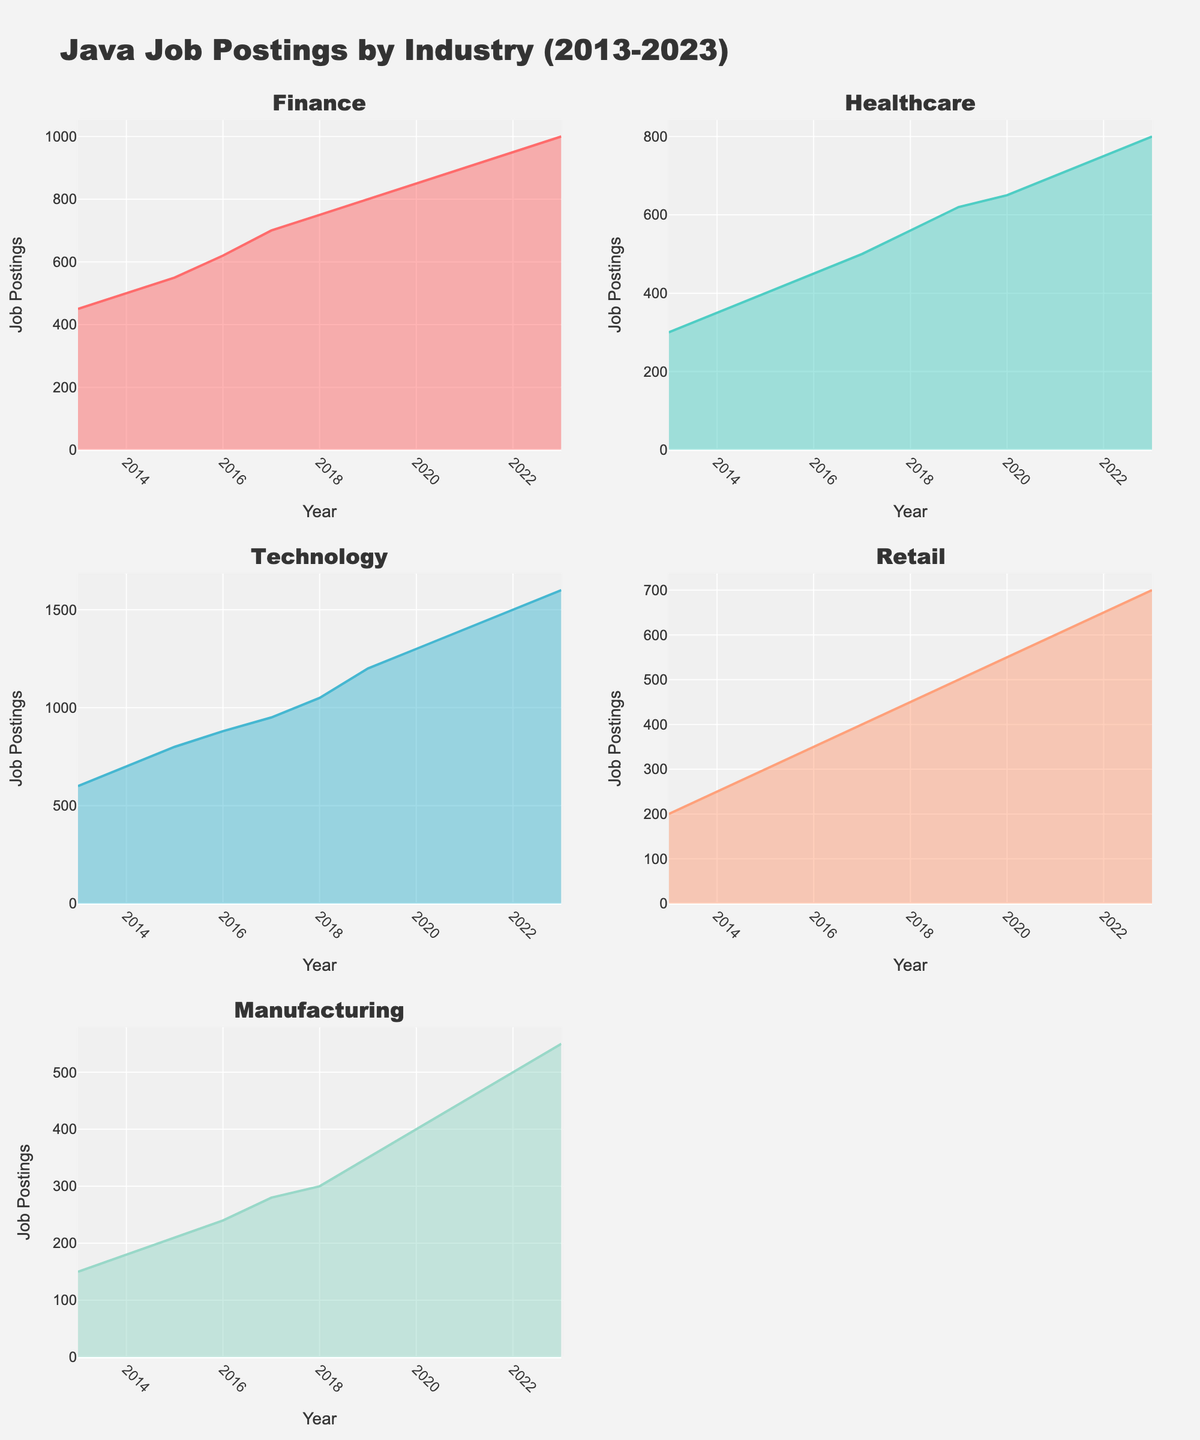What's the title of the figure? The title of the figure is usually found at the top. It reads "Java Job Postings by Industry (2013-2023)".
Answer: Java Job Postings by Industry (2013-2023) Which industry had the highest number of job postings in 2023? By comparing the height of the area charts in 2023, the Technology industry has the highest number of job postings.
Answer: Technology How did job postings in the Healthcare industry change from 2013 to 2023? To find the changes, look at the area chart for the Healthcare industry in 2013 and 2023. The number of job postings in 2013 was 300 and increased to 800 in 2023.
Answer: Increased from 300 to 800 What is the trend of job postings in the Manufacturing industry over the years? Observe the shape of the area chart for Manufacturing. From 2013 to 2023, the job postings show a rising trend, starting at 150 and going up to 550.
Answer: Rising trend Which year had the lowest number of Finance job postings? By examining the area chart for the Finance industry, 2013 had the lowest job postings, with 450 postings.
Answer: 2013 In which year did the Technology industry see the largest increase in job postings from the previous year? Check the year-over-year differences in the area chart for Technology. The largest increase occurred from 2018 to 2019, with an increase of 150 postings (from 1050 to 1200).
Answer: 2019 How many subplots are there for different industries in the figure? Count the number of separate area charts (subplots) in the figure, which cover Finance, Healthcare, Technology, Retail, and Manufacturing, making a total of 5 subplots.
Answer: 5 Compare the job postings between the Retail and Manufacturing industries in 2020. Which has more job postings and by how much? Look at the heights of the areas for Retail and Manufacturing in 2020. Retail had 550 postings, and Manufacturing had 400 postings, resulting in 150 more postings for Retail.
Answer: Retail by 150 What is the average number of job postings in the Finance industry across the years? Sum all Finance job postings (450+500+550+620+700+750+800+850+900+950+1000) = 8070 and divide by the number of years (11). The average is 8070/11 ≈ 734.
Answer: 734 